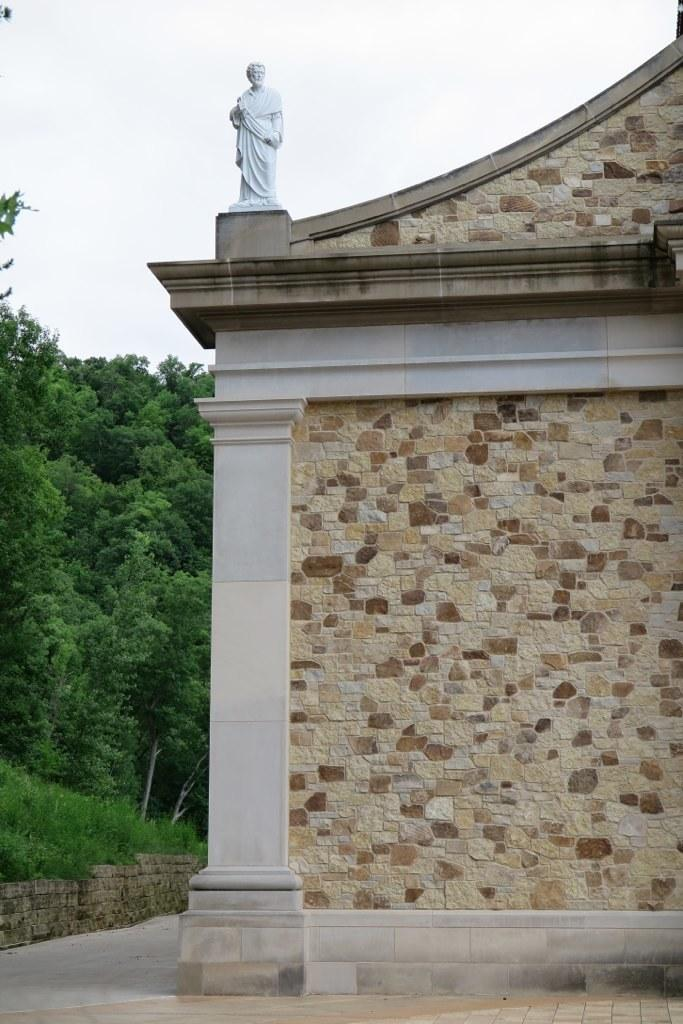What is depicted on the house in the image? There is a sculpture of a person on the house. What can be seen in the background of the image? There are plants, trees, and the sky visible in the background of the image. What type of songs can be heard coming from the clock in the image? There is no clock present in the image, so it's not possible to determine what, if any, songs might be heard. 